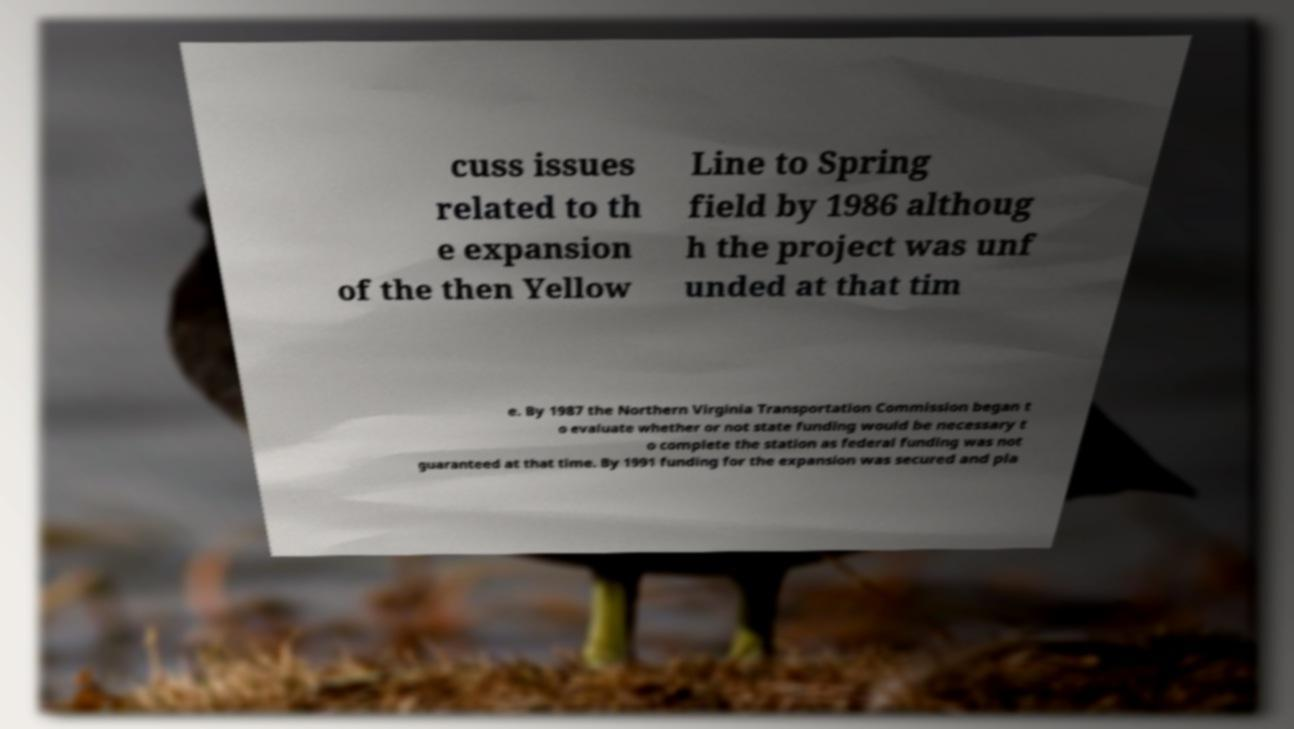For documentation purposes, I need the text within this image transcribed. Could you provide that? cuss issues related to th e expansion of the then Yellow Line to Spring field by 1986 althoug h the project was unf unded at that tim e. By 1987 the Northern Virginia Transportation Commission began t o evaluate whether or not state funding would be necessary t o complete the station as federal funding was not guaranteed at that time. By 1991 funding for the expansion was secured and pla 